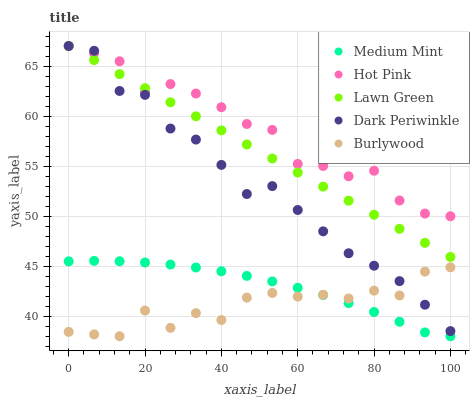Does Burlywood have the minimum area under the curve?
Answer yes or no. Yes. Does Hot Pink have the maximum area under the curve?
Answer yes or no. Yes. Does Lawn Green have the minimum area under the curve?
Answer yes or no. No. Does Lawn Green have the maximum area under the curve?
Answer yes or no. No. Is Lawn Green the smoothest?
Answer yes or no. Yes. Is Burlywood the roughest?
Answer yes or no. Yes. Is Hot Pink the smoothest?
Answer yes or no. No. Is Hot Pink the roughest?
Answer yes or no. No. Does Medium Mint have the lowest value?
Answer yes or no. Yes. Does Lawn Green have the lowest value?
Answer yes or no. No. Does Dark Periwinkle have the highest value?
Answer yes or no. Yes. Does Burlywood have the highest value?
Answer yes or no. No. Is Burlywood less than Lawn Green?
Answer yes or no. Yes. Is Dark Periwinkle greater than Medium Mint?
Answer yes or no. Yes. Does Medium Mint intersect Burlywood?
Answer yes or no. Yes. Is Medium Mint less than Burlywood?
Answer yes or no. No. Is Medium Mint greater than Burlywood?
Answer yes or no. No. Does Burlywood intersect Lawn Green?
Answer yes or no. No. 